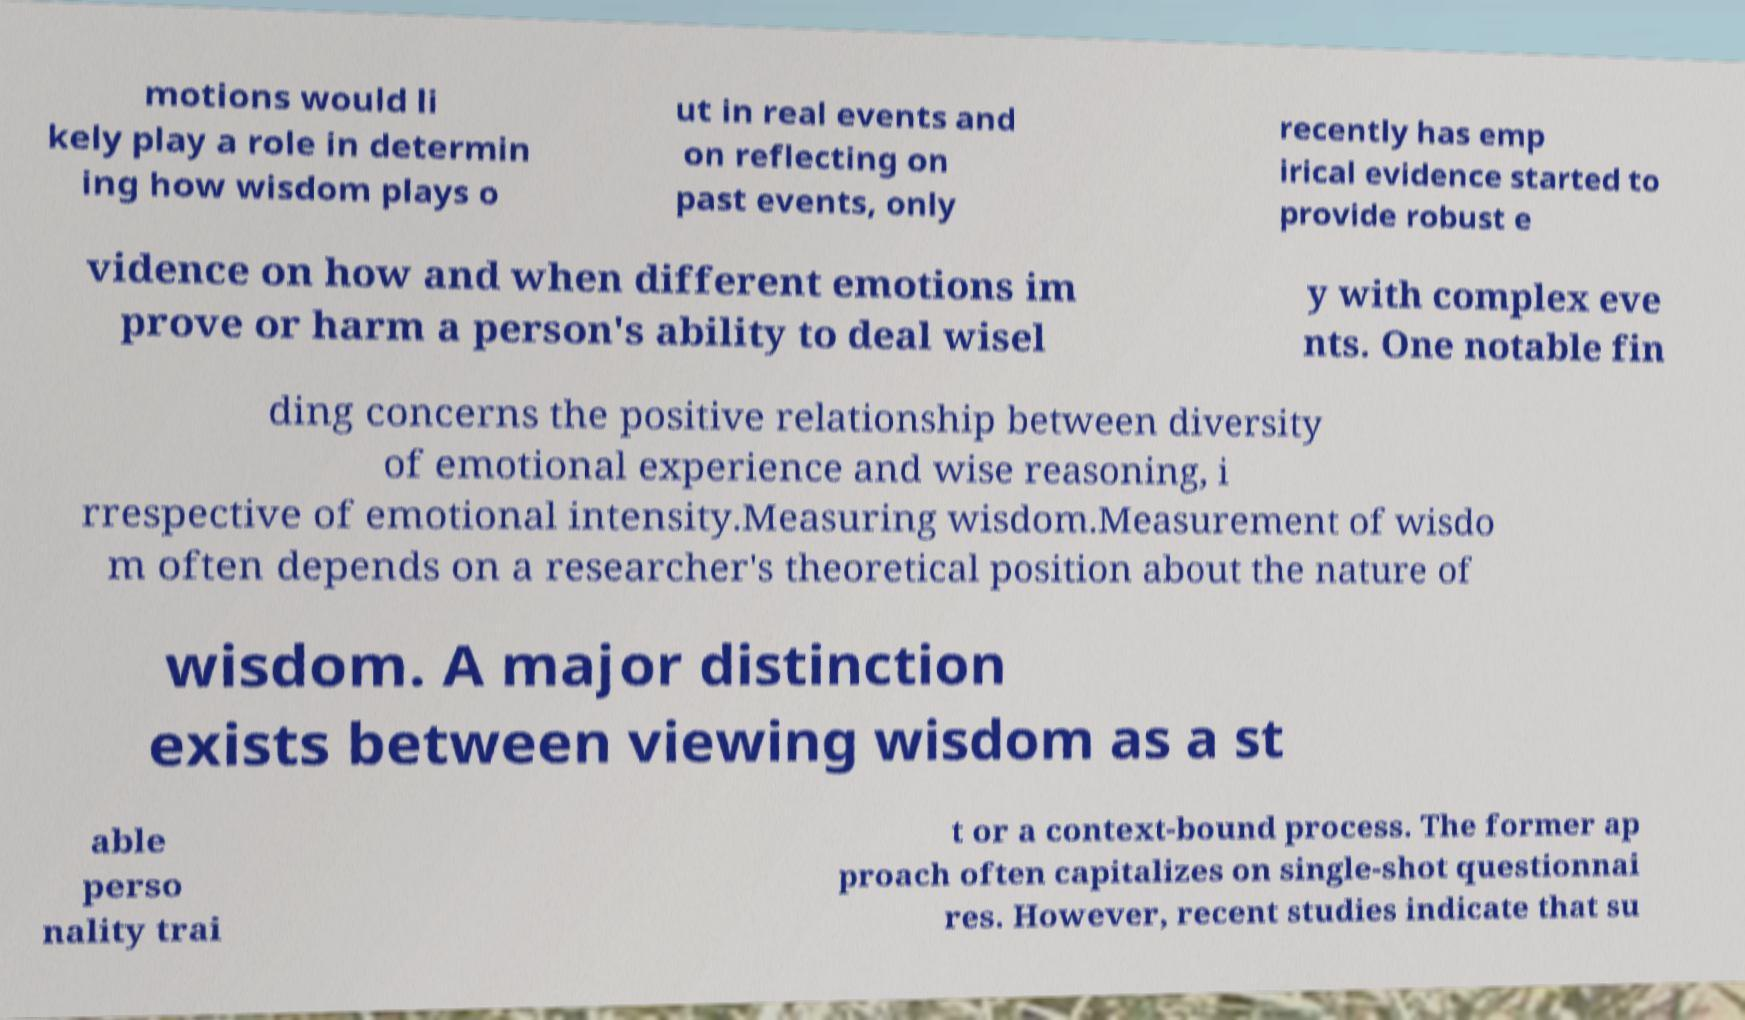Please identify and transcribe the text found in this image. motions would li kely play a role in determin ing how wisdom plays o ut in real events and on reflecting on past events, only recently has emp irical evidence started to provide robust e vidence on how and when different emotions im prove or harm a person's ability to deal wisel y with complex eve nts. One notable fin ding concerns the positive relationship between diversity of emotional experience and wise reasoning, i rrespective of emotional intensity.Measuring wisdom.Measurement of wisdo m often depends on a researcher's theoretical position about the nature of wisdom. A major distinction exists between viewing wisdom as a st able perso nality trai t or a context-bound process. The former ap proach often capitalizes on single-shot questionnai res. However, recent studies indicate that su 